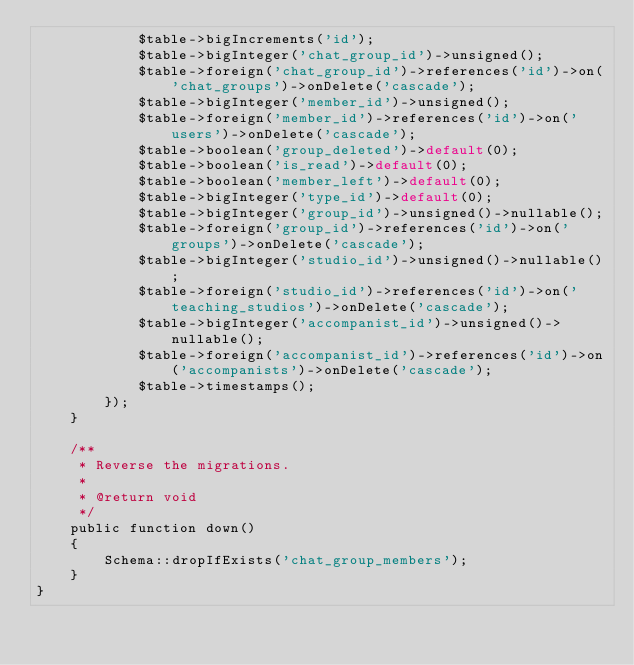Convert code to text. <code><loc_0><loc_0><loc_500><loc_500><_PHP_>            $table->bigIncrements('id');
            $table->bigInteger('chat_group_id')->unsigned();
            $table->foreign('chat_group_id')->references('id')->on('chat_groups')->onDelete('cascade');
            $table->bigInteger('member_id')->unsigned();
            $table->foreign('member_id')->references('id')->on('users')->onDelete('cascade');
            $table->boolean('group_deleted')->default(0);
            $table->boolean('is_read')->default(0);
            $table->boolean('member_left')->default(0);
            $table->bigInteger('type_id')->default(0);
            $table->bigInteger('group_id')->unsigned()->nullable();
            $table->foreign('group_id')->references('id')->on('groups')->onDelete('cascade');
            $table->bigInteger('studio_id')->unsigned()->nullable();
            $table->foreign('studio_id')->references('id')->on('teaching_studios')->onDelete('cascade');
            $table->bigInteger('accompanist_id')->unsigned()->nullable();
            $table->foreign('accompanist_id')->references('id')->on('accompanists')->onDelete('cascade');
            $table->timestamps();
        });
    }

    /**
     * Reverse the migrations.
     *
     * @return void
     */
    public function down()
    {
        Schema::dropIfExists('chat_group_members');
    }
}
</code> 